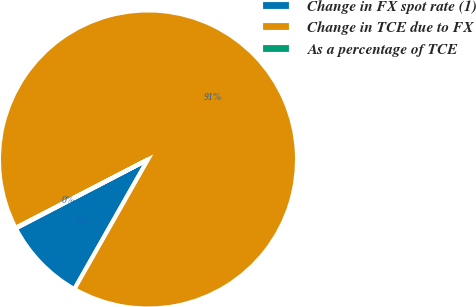Convert chart to OTSL. <chart><loc_0><loc_0><loc_500><loc_500><pie_chart><fcel>Change in FX spot rate (1)<fcel>Change in TCE due to FX<fcel>As a percentage of TCE<nl><fcel>9.13%<fcel>90.81%<fcel>0.06%<nl></chart> 